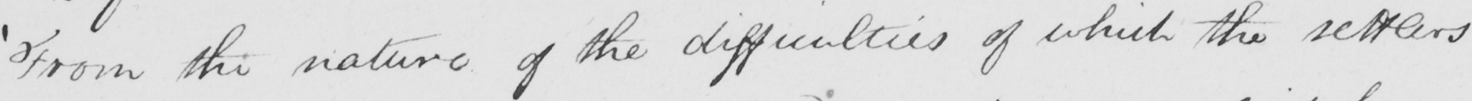Please provide the text content of this handwritten line. ' From the nature of the difficulties of which the settlers 